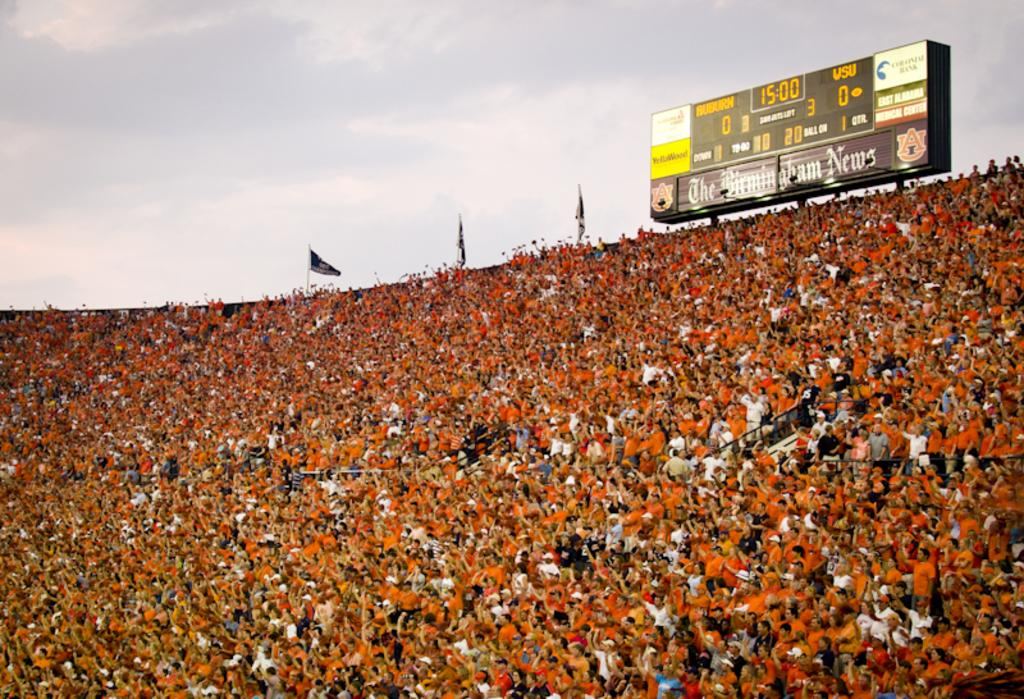<image>
Summarize the visual content of the image. The scoreboard says that WSU currently has zero points. 